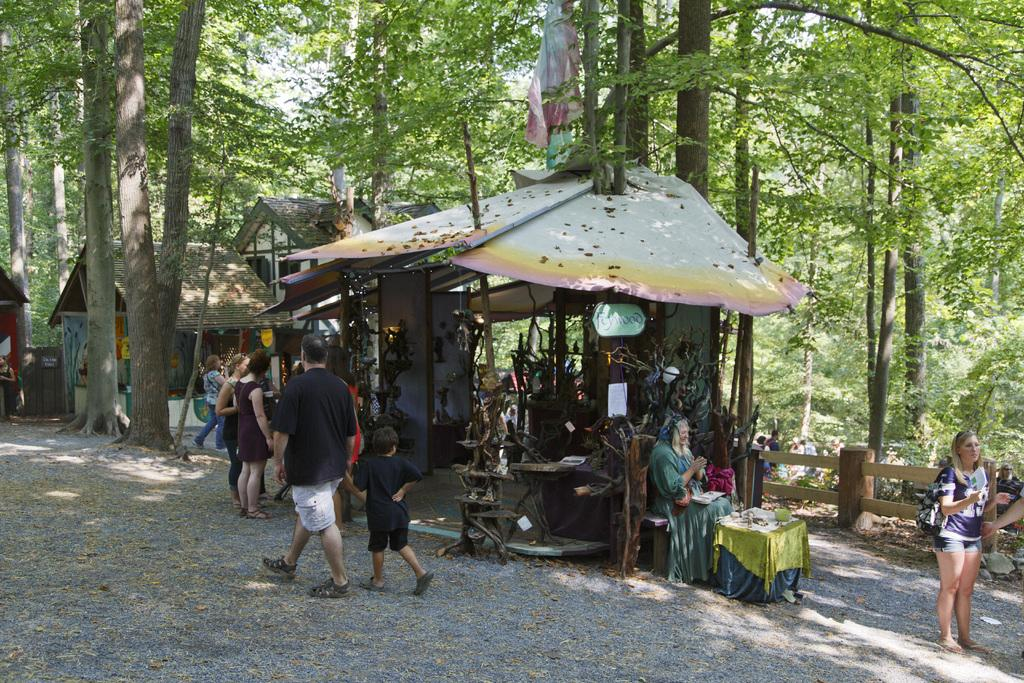What is the main subject of the image? There is a man in the image. What is the man doing in the image? The man is walking in the image. What is the man wearing in the image? The man is wearing a black t-shirt in the image. What is the man holding in the image? The man is holding a child in the image. Who else is present in the image? There is a woman in the image. Where is the woman located in the image? The woman is standing on the right side in the image. What can be seen in the background of the image? There are trees in the image. What type of sponge is being used by the man to clean the base in the image? There is no sponge or base present in the image; the man is walking while holding a child. What color is the scarf worn by the woman in the image? There is no scarf present in the image; the woman is standing on the right side without any visible accessories. 